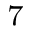Convert formula to latex. <formula><loc_0><loc_0><loc_500><loc_500>^ { 7 }</formula> 